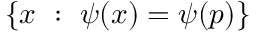Convert formula to latex. <formula><loc_0><loc_0><loc_500><loc_500>\{ x \ \colon \ \psi ( x ) = \psi ( p ) \}</formula> 